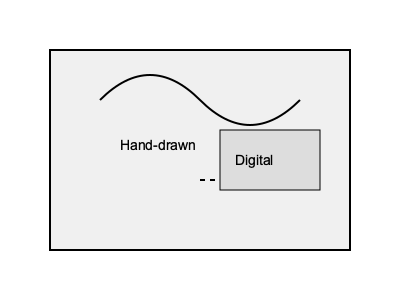In designing a Zine layout that combines your friend's poems with hand-drawn illustrations, you want to integrate digital elements seamlessly. What technique would be most effective for blending the hand-drawn curve with the digital rectangle in the diagram, while maintaining the Zine's organic feel? To effectively blend hand-drawn illustrations with digital elements in a Zine layout while maintaining an organic feel, consider the following steps:

1. Analyze the hand-drawn curve: Notice its natural, flowing quality that represents the organic nature of hand-drawn elements.

2. Observe the digital rectangle: It has sharp edges and a uniform fill, typical of digital design elements.

3. Identify the transition point: The dashed line indicates where the two elements meet and need to be integrated.

4. Consider blending techniques:
   a) Mask blending: Use a soft-edged mask to fade the digital element into the hand-drawn area.
   b) Texture overlay: Apply a paper or grain texture over both elements to unify them.
   c) Vector tracing: Convert the hand-drawn element to a vector path and adjust its endpoints to match the digital element.
   d) Opacity gradients: Gradually reduce the opacity of the digital element as it approaches the hand-drawn area.

5. Evaluate the most effective technique: In this case, mask blending would be most effective because:
   - It preserves the integrity of both the hand-drawn and digital elements.
   - It creates a smooth transition that maintains the organic feel of the Zine.
   - It allows for easy adjustments and experimentation with the blend's intensity.

6. Implementation: Use a soft-edged brush in image editing software to create a mask that gradually reveals the digital element, blending it seamlessly with the hand-drawn curve.

7. Fine-tuning: Adjust the mask's opacity and edge softness to achieve the desired blend while ensuring the Zine's overall organic aesthetic is maintained.
Answer: Mask blending 